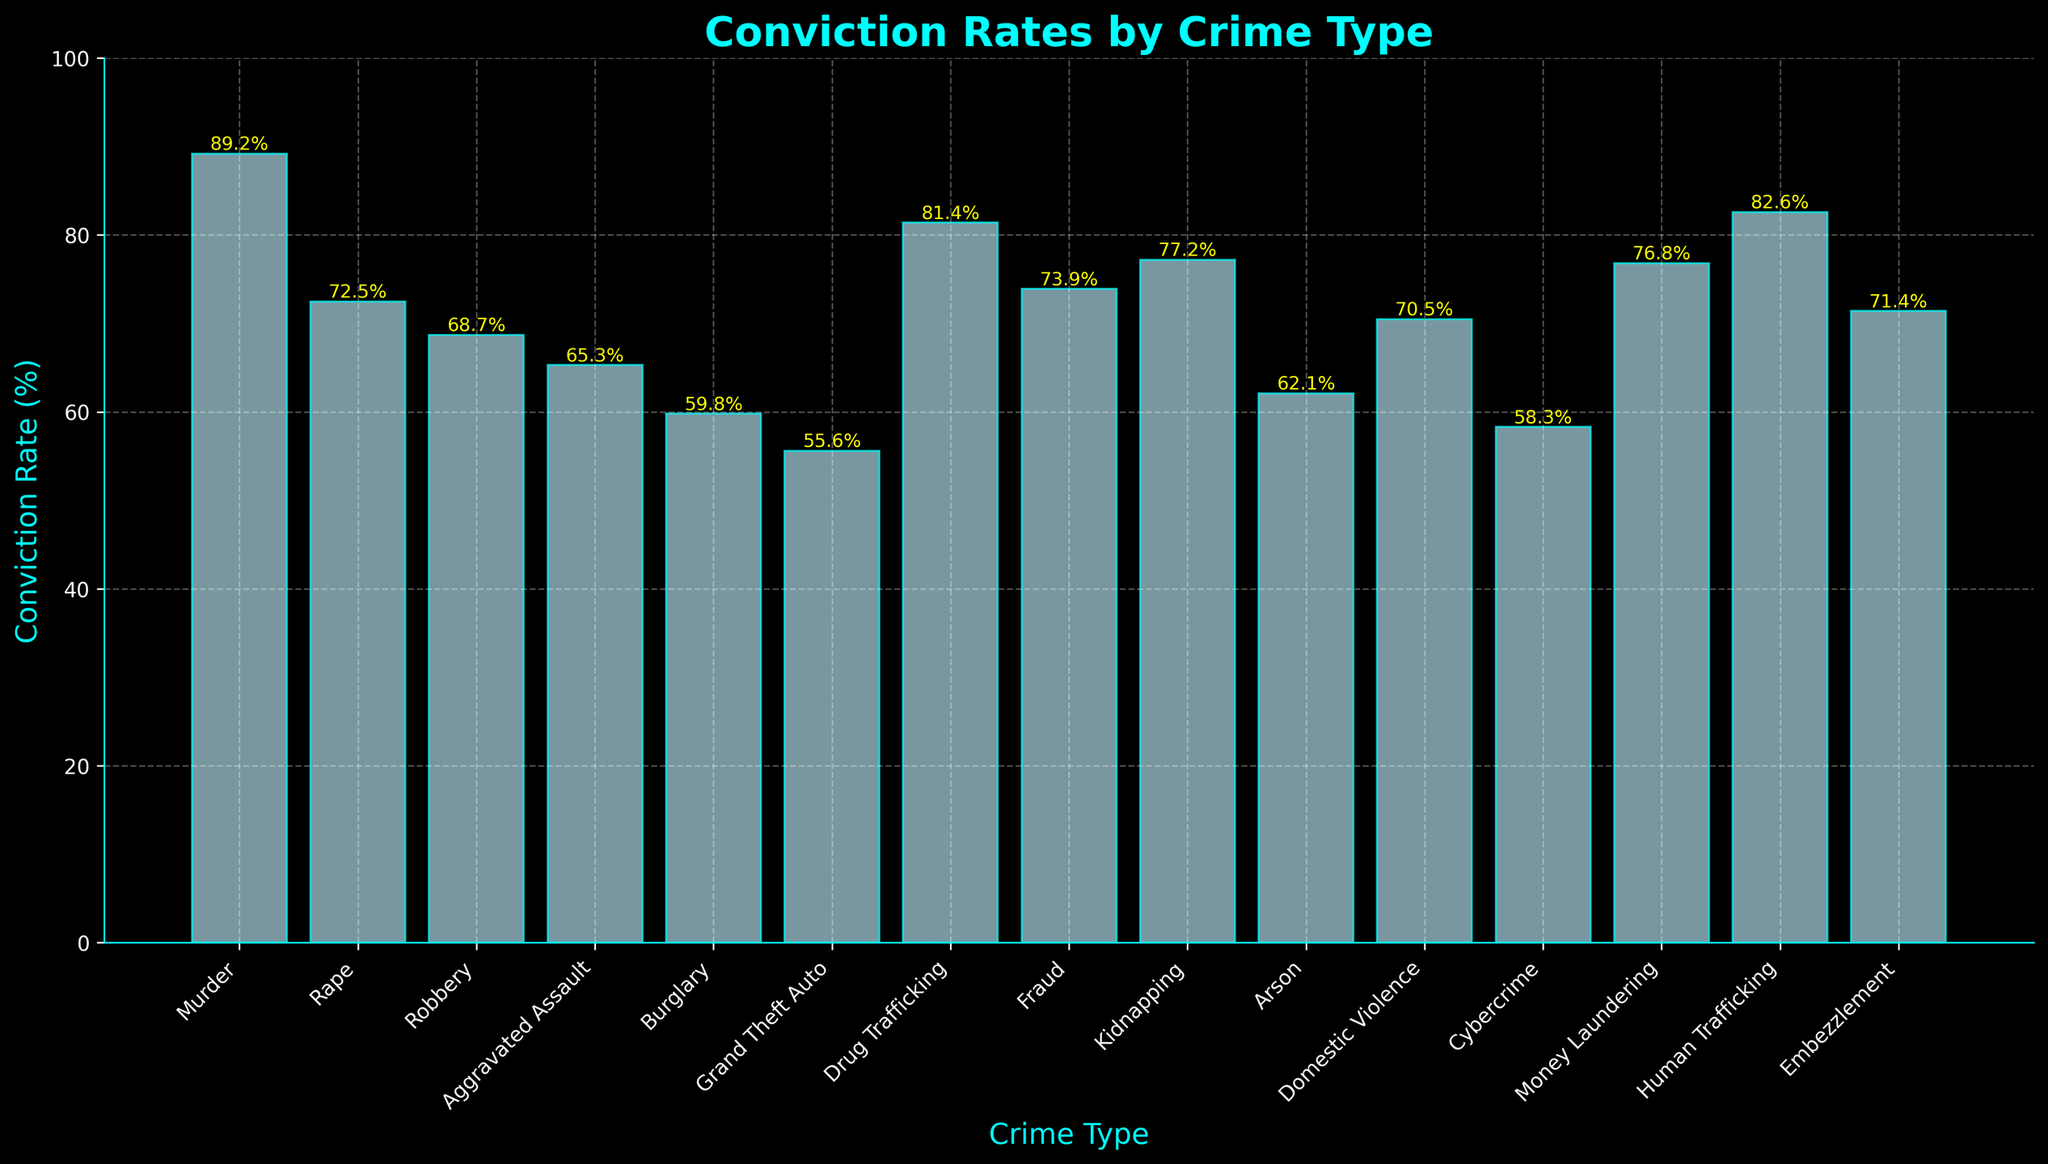Which crime has the highest conviction rate? The crime with the highest bar in the chart represents the highest conviction rate. The bar for "Murder" is the tallest, indicating the highest conviction rate.
Answer: Murder Which crime has the lowest conviction rate? The crime with the lowest bar in the chart represents the lowest conviction rate. The bar for "Grand Theft Auto" is the shortest, indicating the lowest conviction rate.
Answer: Grand Theft Auto What's the difference in conviction rates between Murder and Grand Theft Auto? Identify the conviction rates for Murder (89.2%) and Grand Theft Auto (55.6%). The difference between the two is calculated as 89.2 - 55.6 = 33.6%.
Answer: 33.6% Which crimes have conviction rates greater than 80%? Look for bars that reach above the 80% mark on the y-axis. The bars for "Murder," "Drug Trafficking," and "Human Trafficking" all have conviction rates above 80%.
Answer: Murder, Drug Trafficking, Human Trafficking What is the average conviction rate of Rape, Fraud, and Embezzlement? Identify the conviction rates for Rape (72.5%), Fraud (73.9%), and Embezzlement (71.4%). The average is calculated as (72.5 + 73.9 + 71.4) / 3 = 72.6%.
Answer: 72.6% How many crime types have conviction rates between 60% and 70%? Identify the bars with heights between 60% and 70%. These crime types are "Robbery," "Aggravated Assault," "Burglary," "Arson," and "Domestic Violence," totaling 5 crimes.
Answer: 5 Is the conviction rate of Cybercrime higher or lower than Arson? Compare the heights of the bars for Cybercrime (58.3%) and Arson (62.1%). The bar for Cybercrime is shorter, indicating a lower conviction rate.
Answer: Lower What is the median conviction rate of all crime types? List the conviction rates in ascending order: 55.6, 58.3, 59.8, 62.1, 65.3, 68.7, 70.5, 71.4, 72.5, 73.9, 76.8, 77.2, 81.4, 82.6, 89.2. The median is the middle value in this ordered list, which is 71.4%.
Answer: 71.4% Which has a greater conviction rate, Kidnapping or Domestic Violence? Compare the heights of the bars for Kidnapping (77.2%) and Domestic Violence (70.5%). The bar for Kidnapping is taller, indicating a greater conviction rate.
Answer: Kidnapping 